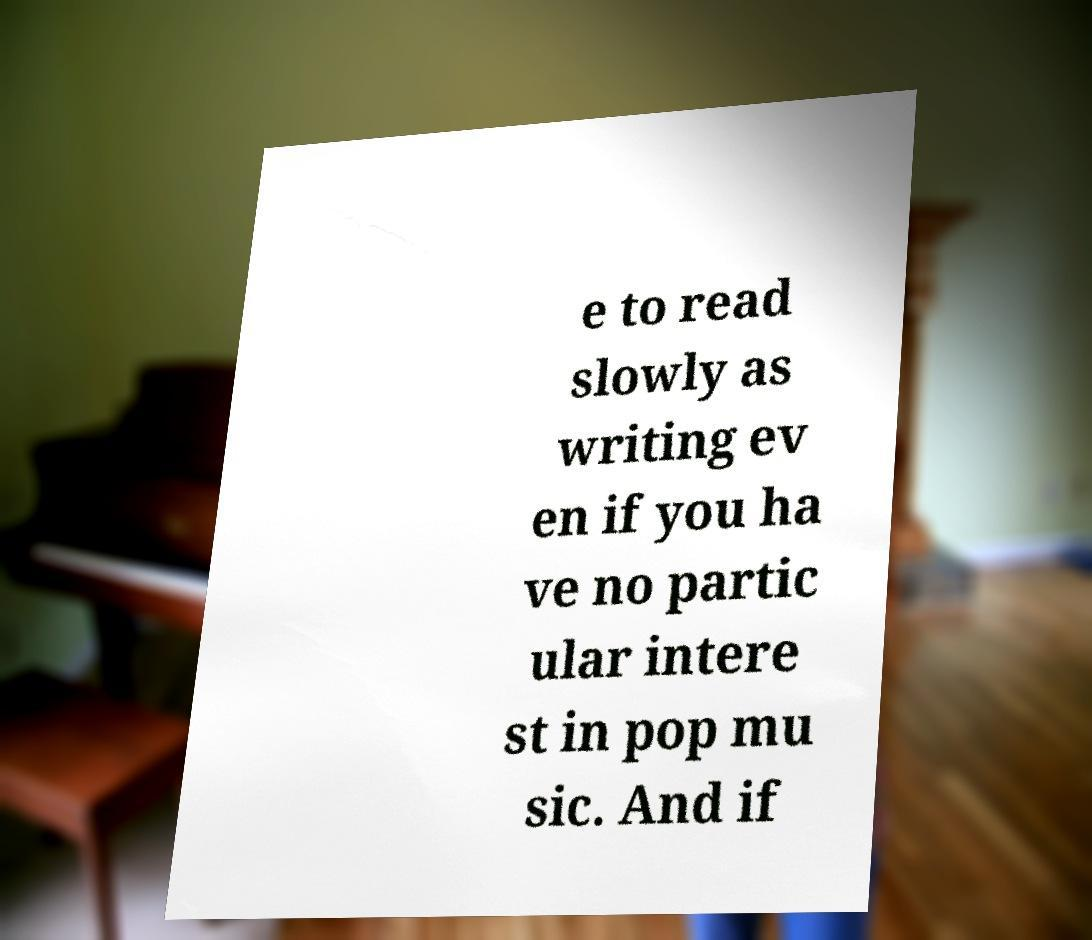What messages or text are displayed in this image? I need them in a readable, typed format. e to read slowly as writing ev en if you ha ve no partic ular intere st in pop mu sic. And if 